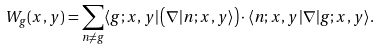Convert formula to latex. <formula><loc_0><loc_0><loc_500><loc_500>W _ { g } ( x , y ) = \sum _ { n \neq g } \langle g ; x , y | \left ( \nabla | n ; x , y \rangle \right ) \cdot \langle n ; x , y | \nabla | g ; x , y \rangle .</formula> 